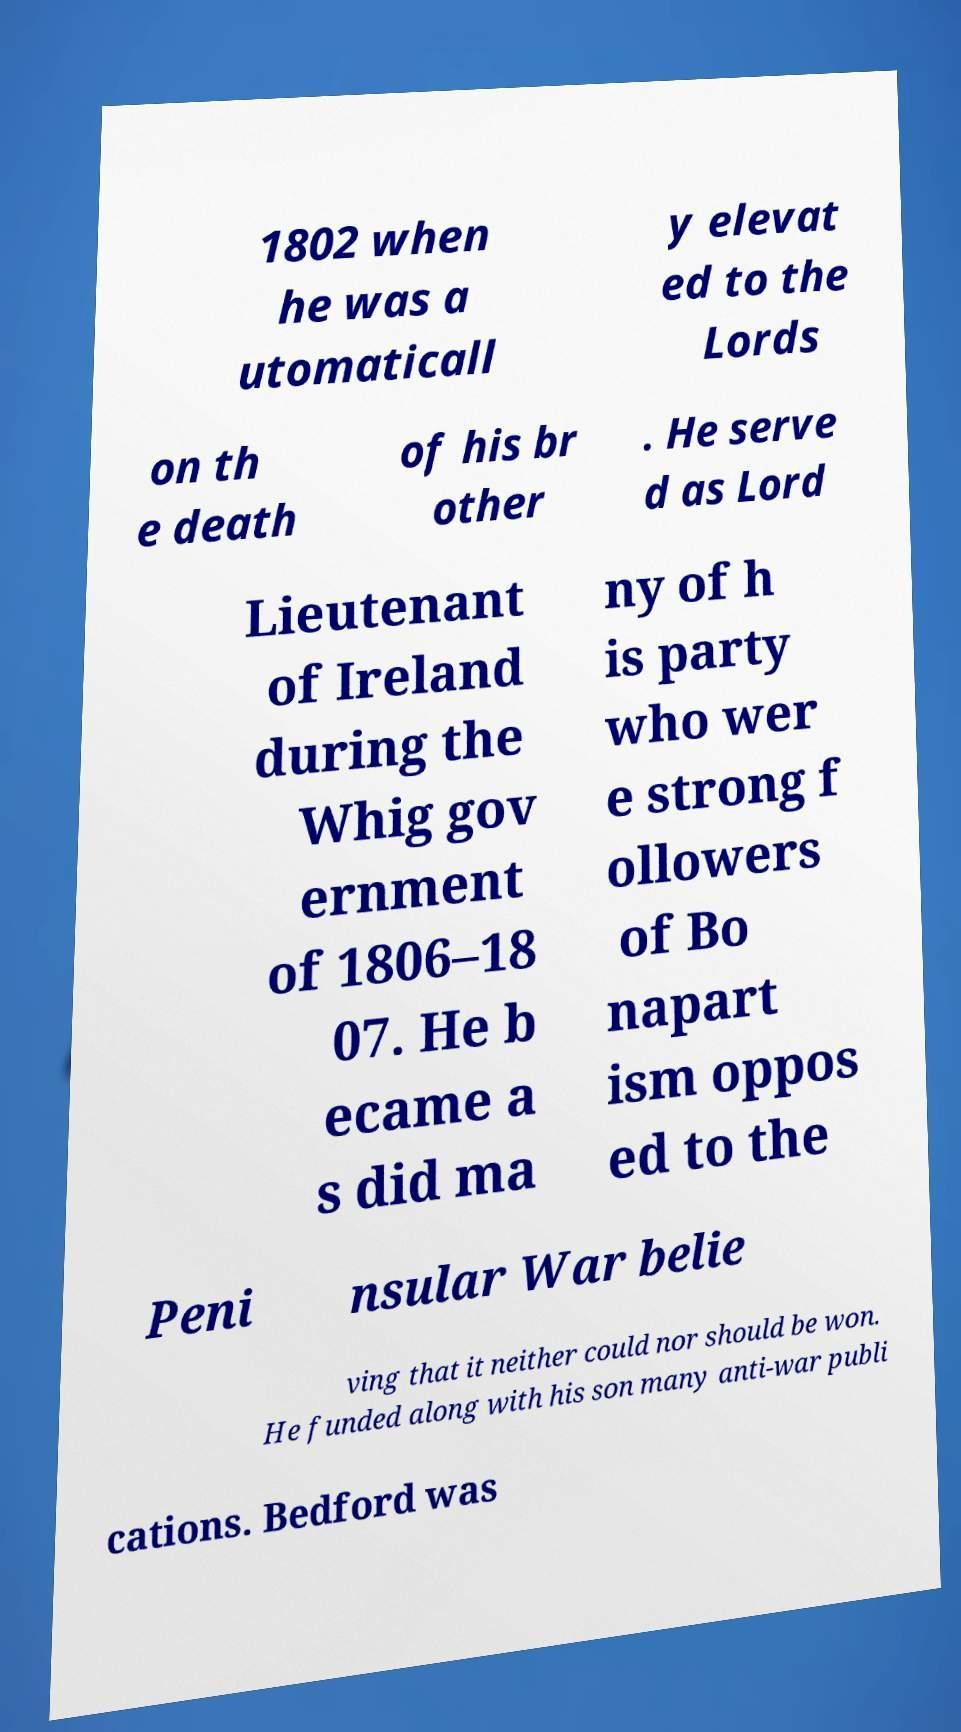There's text embedded in this image that I need extracted. Can you transcribe it verbatim? 1802 when he was a utomaticall y elevat ed to the Lords on th e death of his br other . He serve d as Lord Lieutenant of Ireland during the Whig gov ernment of 1806–18 07. He b ecame a s did ma ny of h is party who wer e strong f ollowers of Bo napart ism oppos ed to the Peni nsular War belie ving that it neither could nor should be won. He funded along with his son many anti-war publi cations. Bedford was 